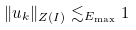Convert formula to latex. <formula><loc_0><loc_0><loc_500><loc_500>\| u _ { k } \| _ { Z ( I ) } \lesssim _ { E _ { \max } } 1</formula> 